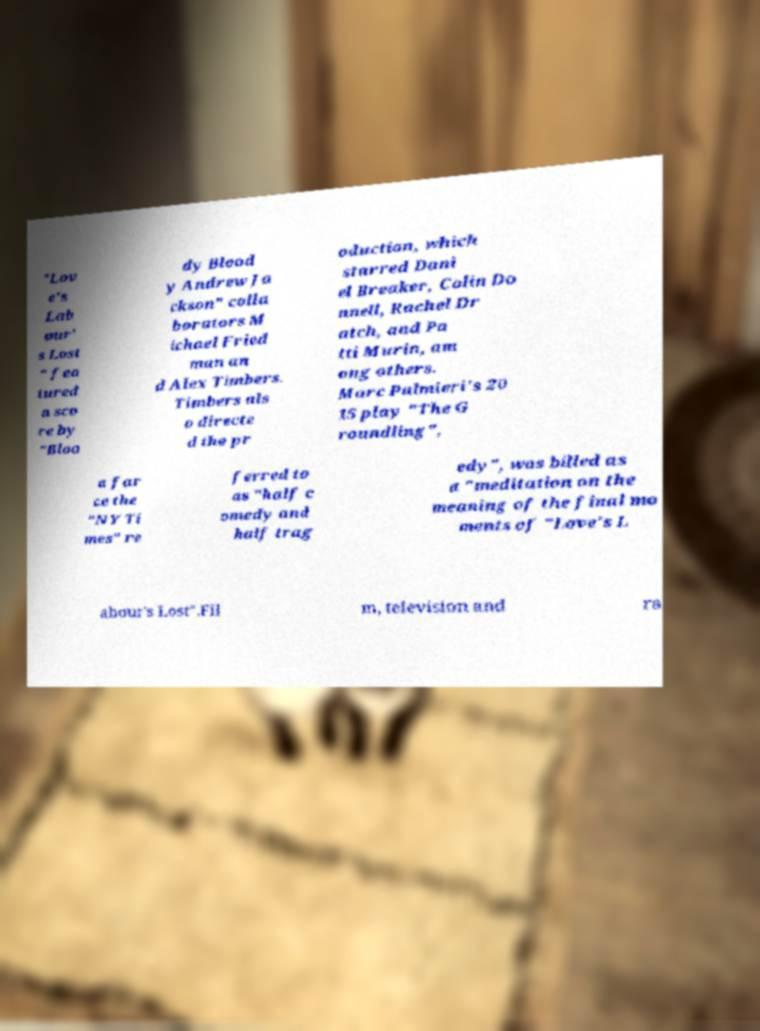Please identify and transcribe the text found in this image. "Lov e's Lab our' s Lost " fea tured a sco re by "Bloo dy Blood y Andrew Ja ckson" colla borators M ichael Fried man an d Alex Timbers. Timbers als o directe d the pr oduction, which starred Dani el Breaker, Colin Do nnell, Rachel Dr atch, and Pa tti Murin, am ong others. Marc Palmieri's 20 15 play "The G roundling", a far ce the "NY Ti mes" re ferred to as "half c omedy and half trag edy", was billed as a "meditation on the meaning of the final mo ments of "Love's L abour's Lost".Fil m, television and ra 